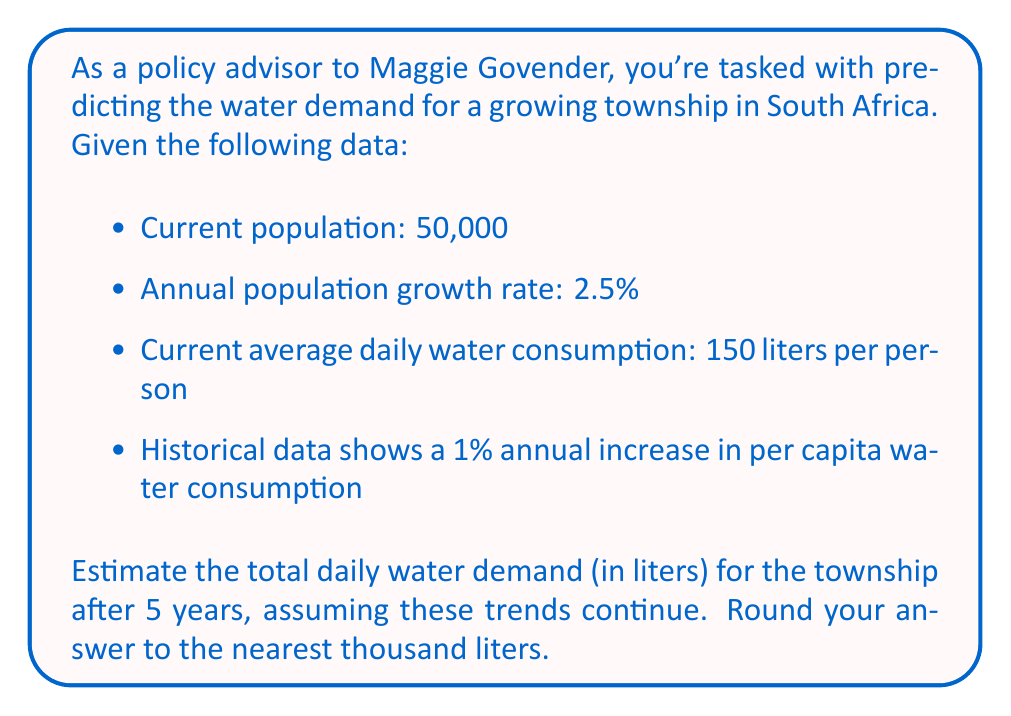Provide a solution to this math problem. Let's approach this step-by-step:

1. Calculate the population after 5 years:
   $P_5 = P_0 \cdot (1 + r)^t$
   Where $P_0$ is initial population, $r$ is growth rate, and $t$ is time in years.
   $P_5 = 50,000 \cdot (1 + 0.025)^5 = 56,571.4$

2. Calculate the per capita water consumption after 5 years:
   $C_5 = C_0 \cdot (1 + i)^t$
   Where $C_0$ is initial consumption, $i$ is annual increase rate.
   $C_5 = 150 \cdot (1 + 0.01)^5 = 157.73$ liters per person

3. Calculate total daily water demand:
   $D_5 = P_5 \cdot C_5$
   $D_5 = 56,571.4 \cdot 157.73 = 8,922,705.82$ liters

4. Round to the nearest thousand:
   $8,923,000$ liters
Answer: 8,923,000 liters 